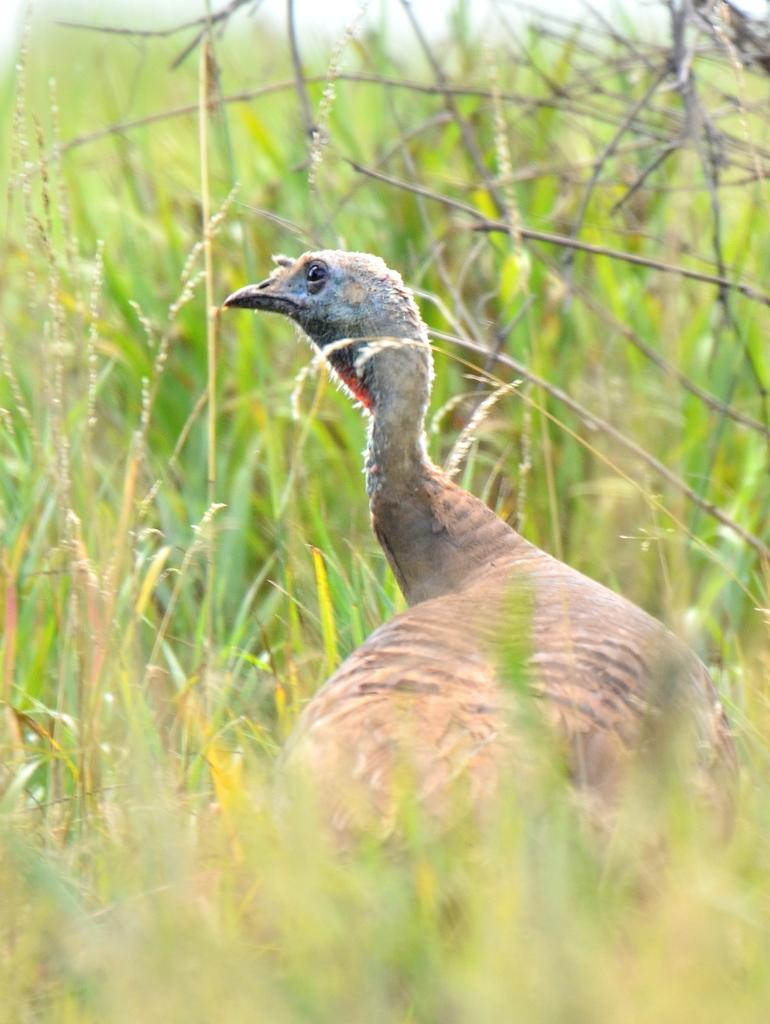What is the main subject of the picture? The main subject of the picture is a bird. Where is the bird located in the picture? The bird is in the middle of the picture. What can be seen in the background of the picture? There is grass visible in the background of the picture. What is the opinion of the goldfish in the image? There is no goldfish present in the image, so it is not possible to determine its opinion. 